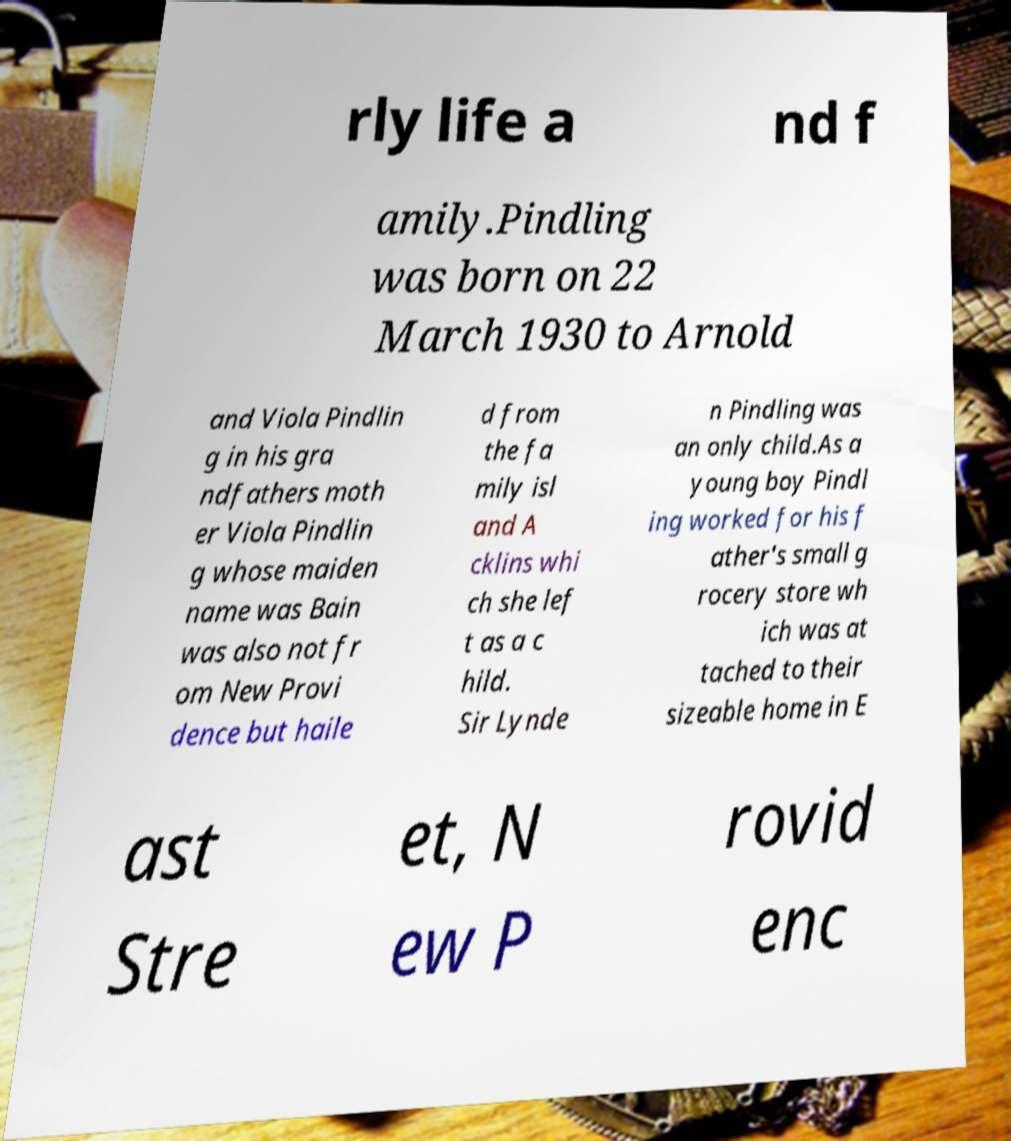For documentation purposes, I need the text within this image transcribed. Could you provide that? rly life a nd f amily.Pindling was born on 22 March 1930 to Arnold and Viola Pindlin g in his gra ndfathers moth er Viola Pindlin g whose maiden name was Bain was also not fr om New Provi dence but haile d from the fa mily isl and A cklins whi ch she lef t as a c hild. Sir Lynde n Pindling was an only child.As a young boy Pindl ing worked for his f ather's small g rocery store wh ich was at tached to their sizeable home in E ast Stre et, N ew P rovid enc 